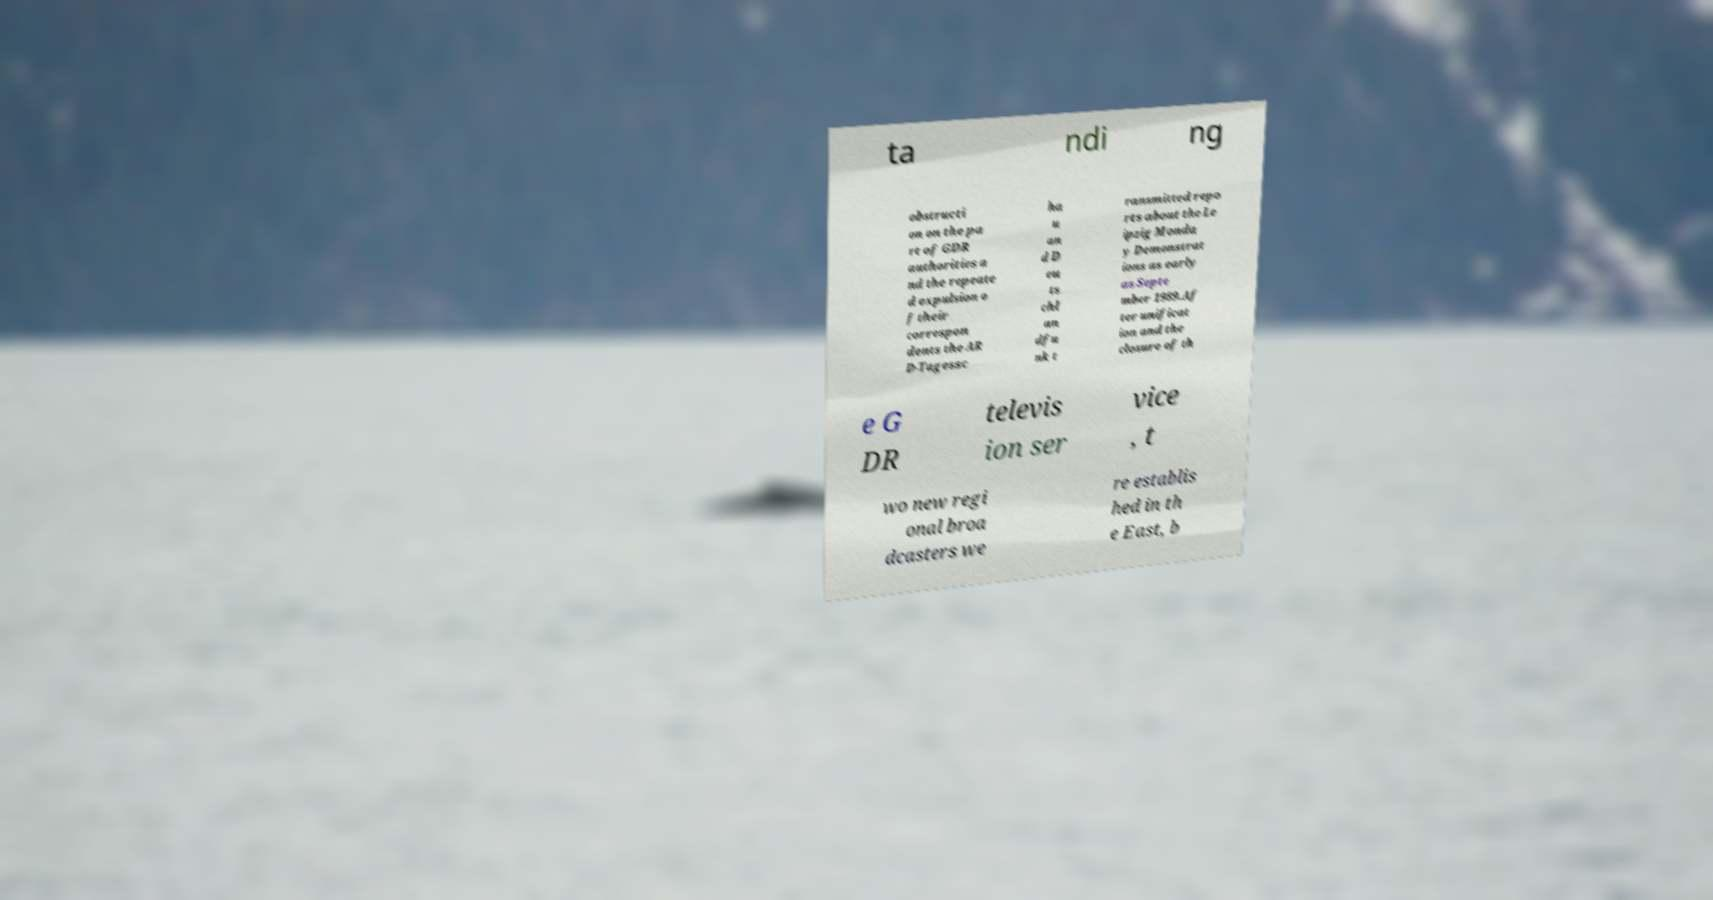Can you accurately transcribe the text from the provided image for me? ta ndi ng obstructi on on the pa rt of GDR authorities a nd the repeate d expulsion o f their correspon dents the AR D-Tagessc ha u an d D eu ts chl an dfu nk t ransmitted repo rts about the Le ipzig Monda y Demonstrat ions as early as Septe mber 1989.Af ter unificat ion and the closure of th e G DR televis ion ser vice , t wo new regi onal broa dcasters we re establis hed in th e East, b 